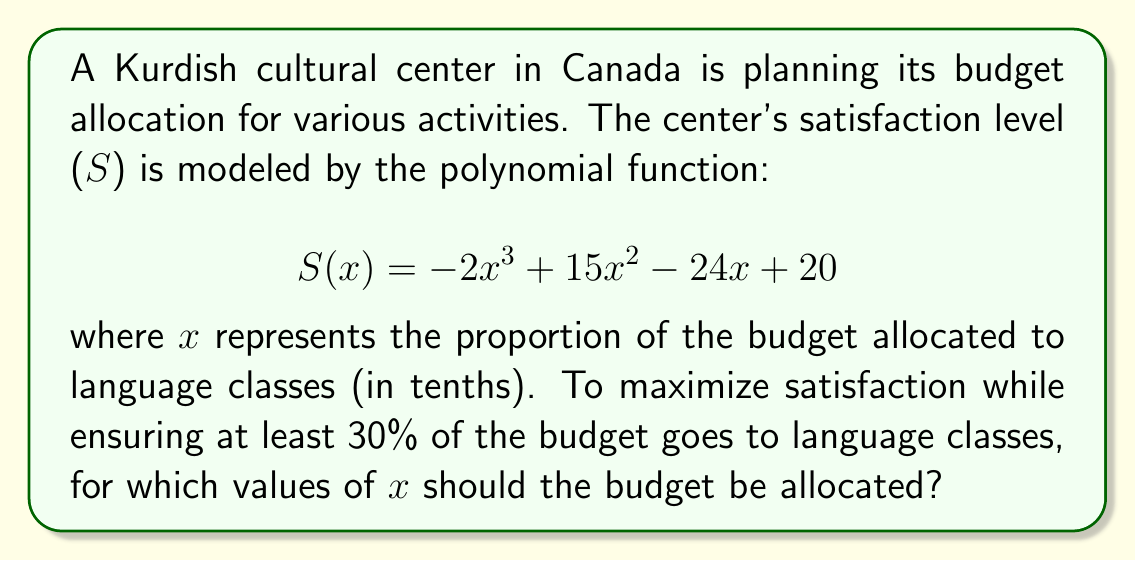What is the answer to this math problem? 1) First, we need to find the critical points of the function by setting its derivative to zero:

   $$S'(x) = -6x^2 + 30x - 24$$
   $$-6x^2 + 30x - 24 = 0$$

2) Solve this quadratic equation:
   $$x = \frac{-b \pm \sqrt{b^2 - 4ac}}{2a}$$
   $$x = \frac{-30 \pm \sqrt{30^2 - 4(-6)(-24)}}{2(-6)}$$
   $$x = \frac{-30 \pm \sqrt{900 - 576}}{-12} = \frac{-30 \pm \sqrt{324}}{-12} = \frac{-30 \pm 18}{-12}$$

3) This gives us two critical points:
   $$x_1 = \frac{-30 + 18}{-12} = 1 \text{ and } x_2 = \frac{-30 - 18}{-12} = 4$$

4) We're told that at least 30% of the budget should go to language classes, so x ≥ 3.

5) Evaluate S(x) at x = 3 and x = 4:
   $$S(3) = -2(3)^3 + 15(3)^2 - 24(3) + 20 = -54 + 135 - 72 + 20 = 29$$
   $$S(4) = -2(4)^3 + 15(4)^2 - 24(4) + 20 = -128 + 240 - 96 + 20 = 36$$

6) S(4) > S(3), so the maximum satisfaction within the constraint is at x = 4.

7) To find the upper bound, we need to solve the inequality:
   $$-2x^3 + 15x^2 - 24x + 20 \geq 36$$
   $$-2x^3 + 15x^2 - 24x - 16 \geq 0$$

8) This cubic inequality is satisfied when 3 ≤ x ≤ 5 (you can verify this by testing points or sketching the graph).

Therefore, to maximize satisfaction while allocating at least 30% to language classes, the budget should be allocated with x between 4 and 5 tenths (40% to 50%).
Answer: $4 \leq x \leq 5$ 